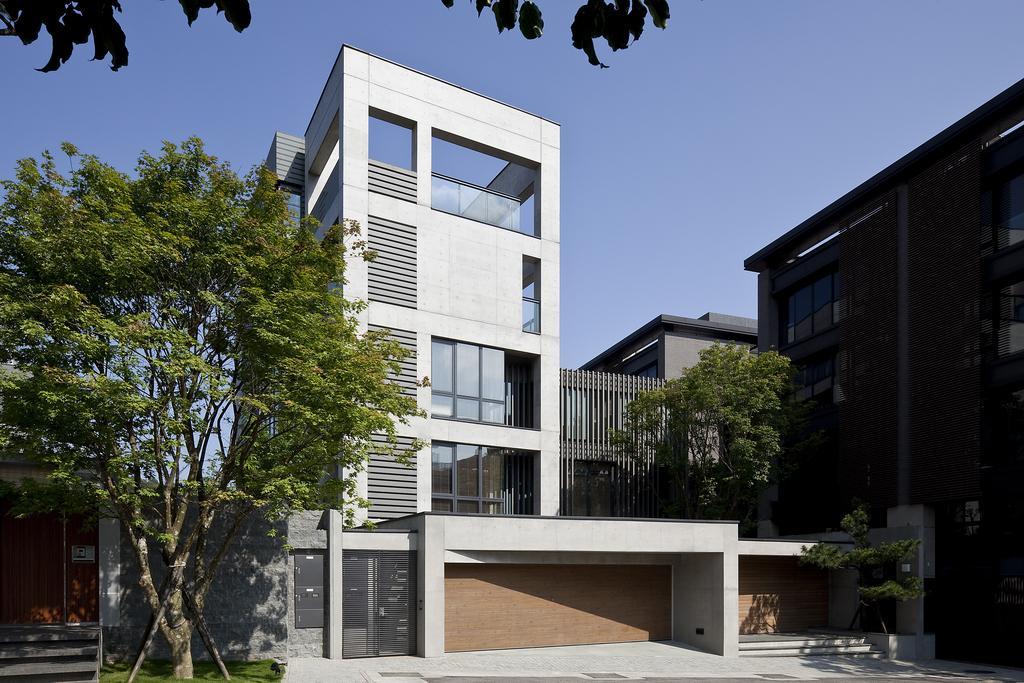Describe this image in one or two sentences. In this image we can see buildings, trees. At the top of the image there is sky. There are gates. 